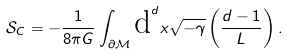<formula> <loc_0><loc_0><loc_500><loc_500>\mathcal { S } _ { C } = - \frac { 1 } { 8 \pi G } \int _ { \partial \mathcal { M } } \text {d} ^ { d } x \sqrt { - \gamma } \left ( \frac { d - 1 } { L } \right ) .</formula> 